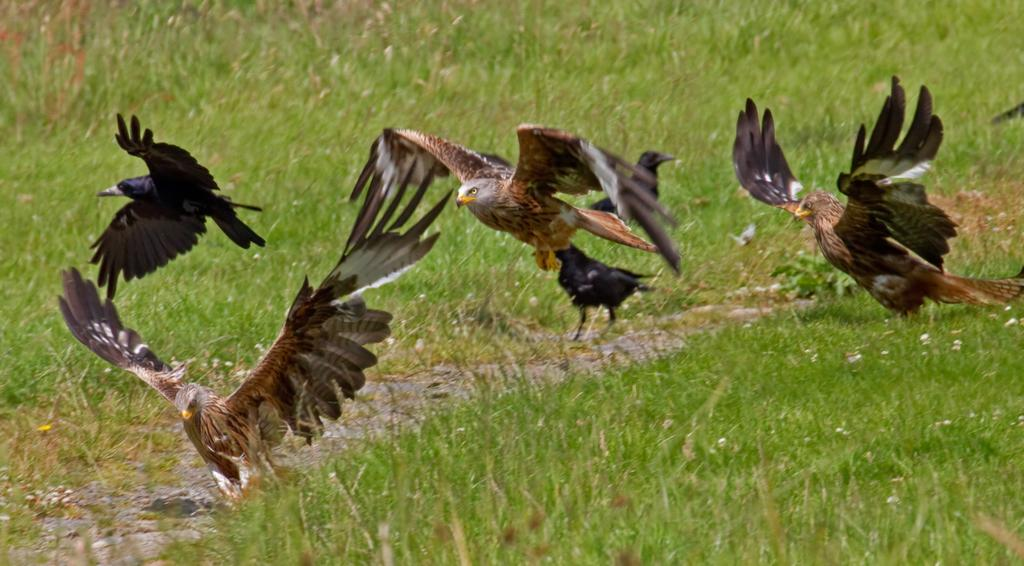What type of birds are in the image? There are brown eagles in the image. What are the eagles doing in the image? Some of the eagles are sitting, and some are flying. Where are the eagles located in the image? The eagles are on a grass field. How many basketballs can be seen in the image? There are no basketballs present in the image. What is the mother of the eagles doing in the image? There is no mother of the eagles depicted in the image. 